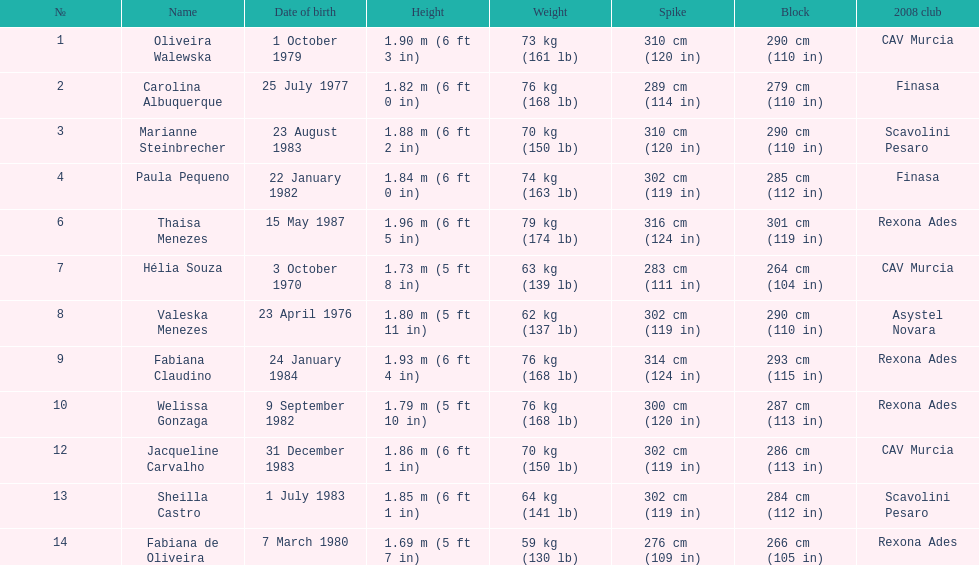Who is the following tallest competitor after thaisa menezes? Fabiana Claudino. 